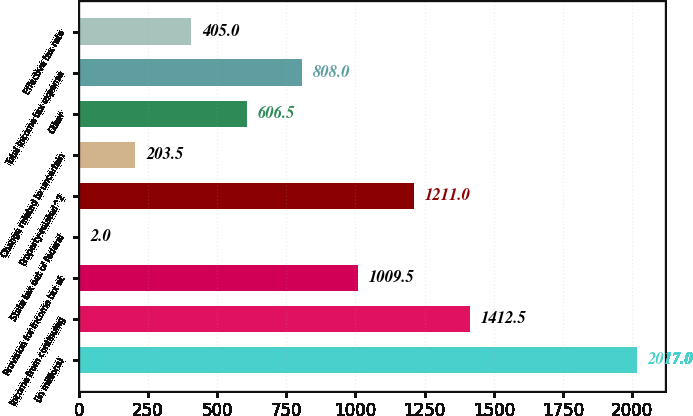Convert chart. <chart><loc_0><loc_0><loc_500><loc_500><bar_chart><fcel>(in millions)<fcel>Income from continuing<fcel>Provision for income tax at<fcel>State tax net of federal<fcel>Property-related^2<fcel>Change related to uncertain<fcel>Other<fcel>Total income tax expense<fcel>Effective tax rate<nl><fcel>2017<fcel>1412.5<fcel>1009.5<fcel>2<fcel>1211<fcel>203.5<fcel>606.5<fcel>808<fcel>405<nl></chart> 